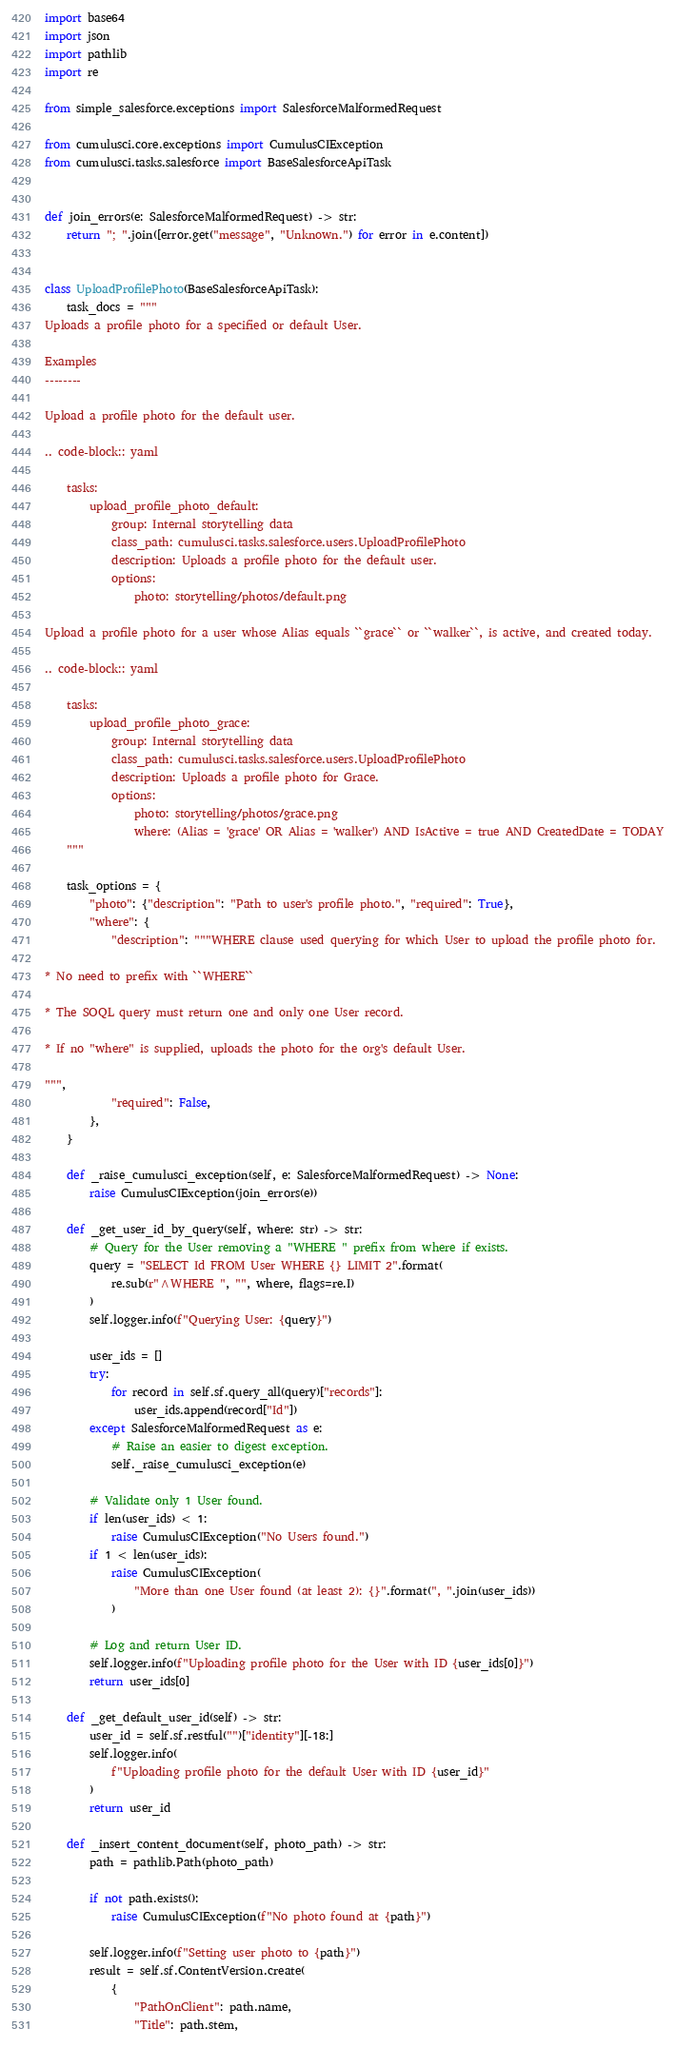<code> <loc_0><loc_0><loc_500><loc_500><_Python_>import base64
import json
import pathlib
import re

from simple_salesforce.exceptions import SalesforceMalformedRequest

from cumulusci.core.exceptions import CumulusCIException
from cumulusci.tasks.salesforce import BaseSalesforceApiTask


def join_errors(e: SalesforceMalformedRequest) -> str:
    return "; ".join([error.get("message", "Unknown.") for error in e.content])


class UploadProfilePhoto(BaseSalesforceApiTask):
    task_docs = """
Uploads a profile photo for a specified or default User.

Examples
--------

Upload a profile photo for the default user.

.. code-block:: yaml

    tasks:
        upload_profile_photo_default:
            group: Internal storytelling data
            class_path: cumulusci.tasks.salesforce.users.UploadProfilePhoto
            description: Uploads a profile photo for the default user.
            options:
                photo: storytelling/photos/default.png

Upload a profile photo for a user whose Alias equals ``grace`` or ``walker``, is active, and created today.

.. code-block:: yaml

    tasks:
        upload_profile_photo_grace:
            group: Internal storytelling data
            class_path: cumulusci.tasks.salesforce.users.UploadProfilePhoto
            description: Uploads a profile photo for Grace.
            options:
                photo: storytelling/photos/grace.png
                where: (Alias = 'grace' OR Alias = 'walker') AND IsActive = true AND CreatedDate = TODAY
    """

    task_options = {
        "photo": {"description": "Path to user's profile photo.", "required": True},
        "where": {
            "description": """WHERE clause used querying for which User to upload the profile photo for.

* No need to prefix with ``WHERE``

* The SOQL query must return one and only one User record.

* If no "where" is supplied, uploads the photo for the org's default User.

""",
            "required": False,
        },
    }

    def _raise_cumulusci_exception(self, e: SalesforceMalformedRequest) -> None:
        raise CumulusCIException(join_errors(e))

    def _get_user_id_by_query(self, where: str) -> str:
        # Query for the User removing a "WHERE " prefix from where if exists.
        query = "SELECT Id FROM User WHERE {} LIMIT 2".format(
            re.sub(r"^WHERE ", "", where, flags=re.I)
        )
        self.logger.info(f"Querying User: {query}")

        user_ids = []
        try:
            for record in self.sf.query_all(query)["records"]:
                user_ids.append(record["Id"])
        except SalesforceMalformedRequest as e:
            # Raise an easier to digest exception.
            self._raise_cumulusci_exception(e)

        # Validate only 1 User found.
        if len(user_ids) < 1:
            raise CumulusCIException("No Users found.")
        if 1 < len(user_ids):
            raise CumulusCIException(
                "More than one User found (at least 2): {}".format(", ".join(user_ids))
            )

        # Log and return User ID.
        self.logger.info(f"Uploading profile photo for the User with ID {user_ids[0]}")
        return user_ids[0]

    def _get_default_user_id(self) -> str:
        user_id = self.sf.restful("")["identity"][-18:]
        self.logger.info(
            f"Uploading profile photo for the default User with ID {user_id}"
        )
        return user_id

    def _insert_content_document(self, photo_path) -> str:
        path = pathlib.Path(photo_path)

        if not path.exists():
            raise CumulusCIException(f"No photo found at {path}")

        self.logger.info(f"Setting user photo to {path}")
        result = self.sf.ContentVersion.create(
            {
                "PathOnClient": path.name,
                "Title": path.stem,</code> 